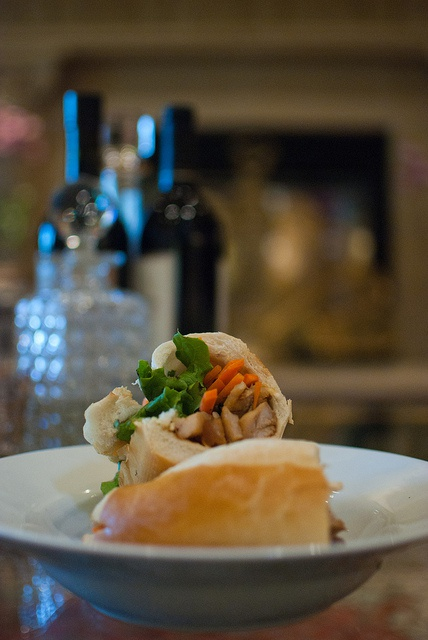Describe the objects in this image and their specific colors. I can see bowl in black, darkgray, olive, and tan tones, sandwich in black, olive, tan, and gray tones, bottle in black and gray tones, bottle in black, gray, and teal tones, and bottle in black, gray, and lightblue tones in this image. 